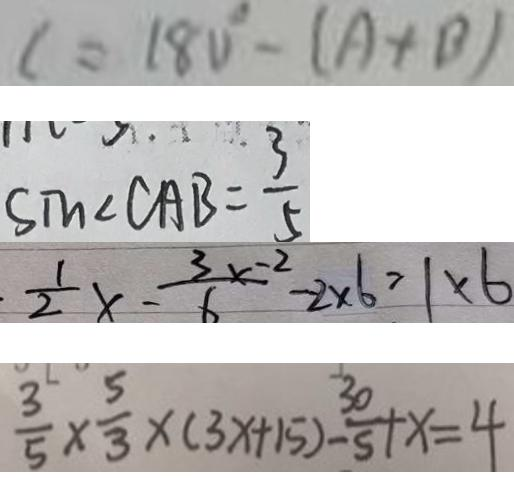<formula> <loc_0><loc_0><loc_500><loc_500>c = 1 8 0 ^ { \circ } - ( A + B ) 
 \sin \angle C A B = \frac { 3 } { 5 } 
 \frac { 1 } { 2 } x - \frac { 3 x - 2 } { 6 } - 2 \times 6 = 1 \times 6 
 \frac { 3 } { 5 } \times \frac { 5 } { 3 } \times ( 3 x + 1 5 ) - \frac { 3 0 } { 5 } + x = 4</formula> 